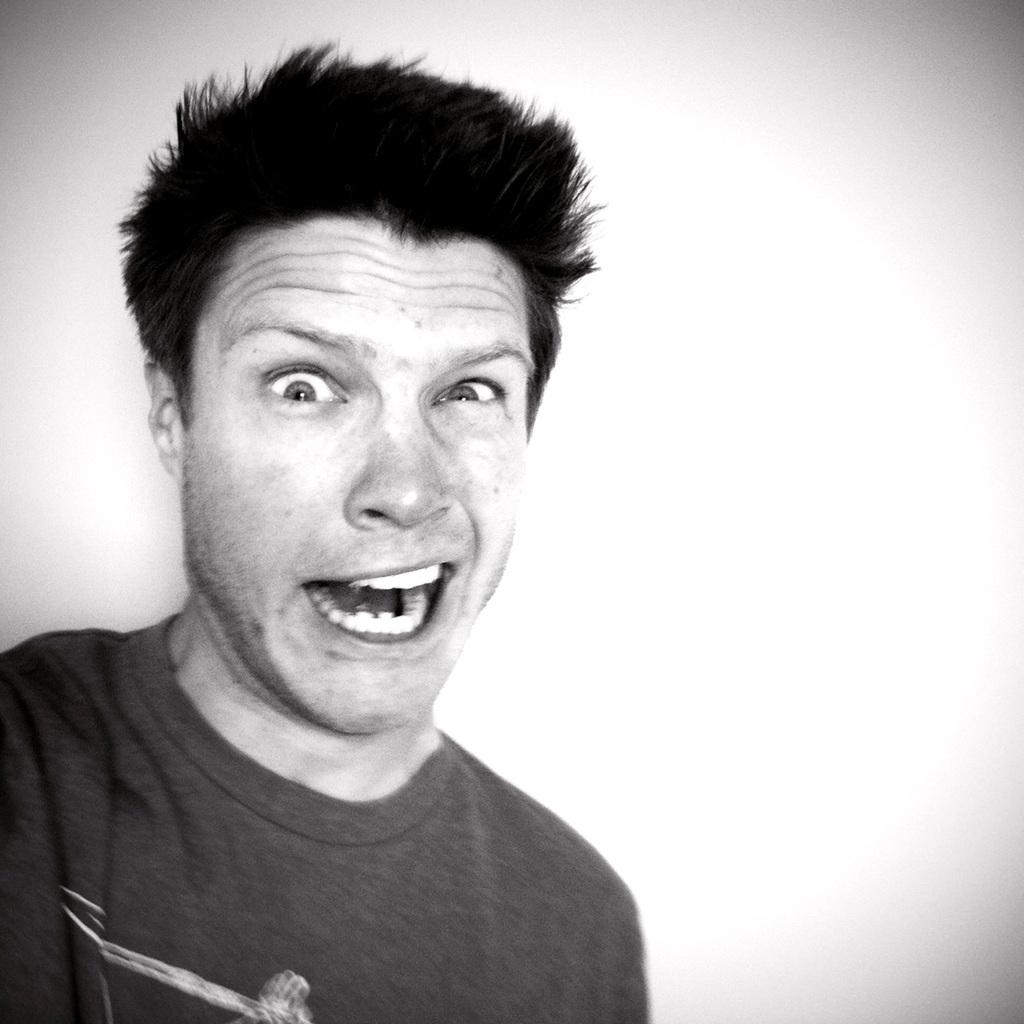Who or what is the main subject in the image? There is a person in the image. What color is the background of the image? The background of the image is white. How many ants can be seen crawling on the person in the image? There are no ants present in the image. What direction is the person turning in the image? The person is not turning in any specific direction in the image; they are stationary. 